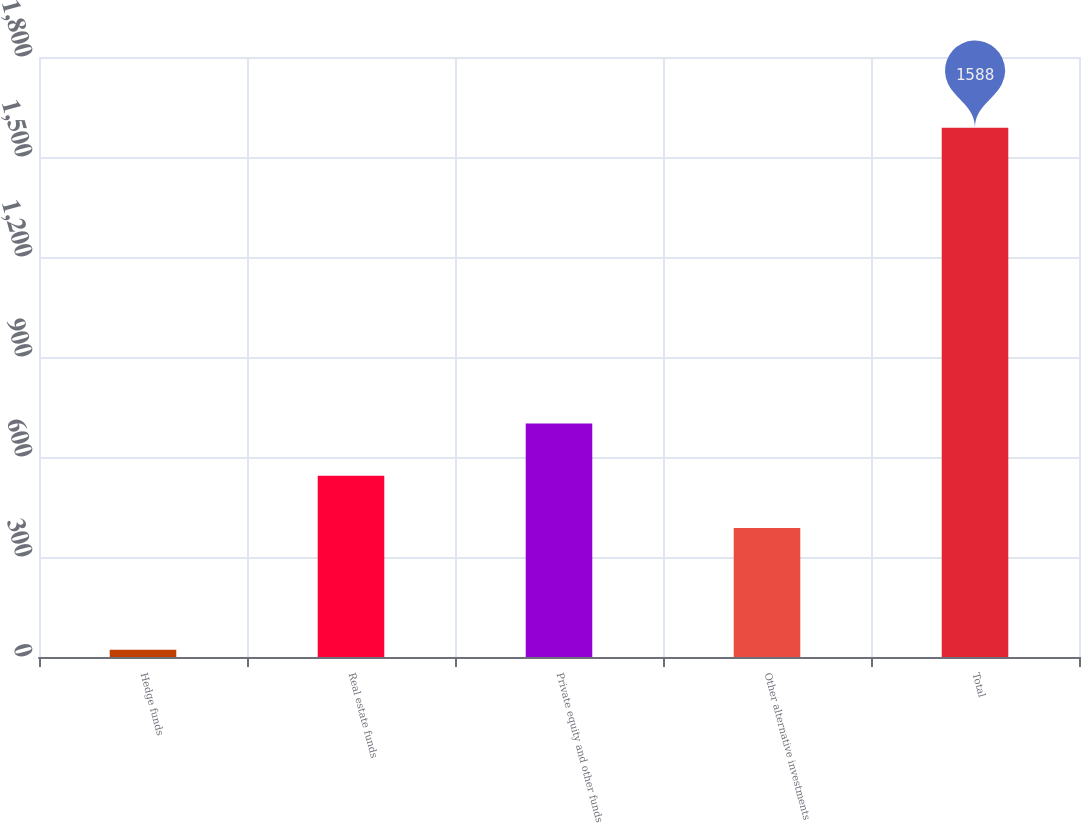Convert chart to OTSL. <chart><loc_0><loc_0><loc_500><loc_500><bar_chart><fcel>Hedge funds<fcel>Real estate funds<fcel>Private equity and other funds<fcel>Other alternative investments<fcel>Total<nl><fcel>22<fcel>543.6<fcel>700.2<fcel>387<fcel>1588<nl></chart> 